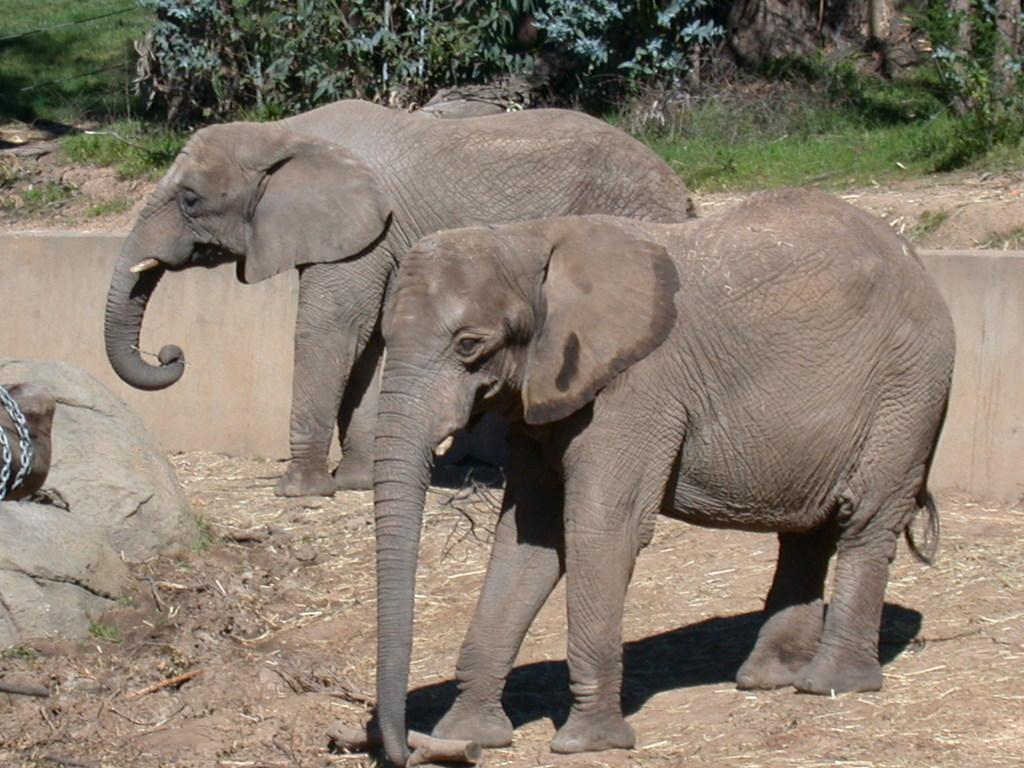What animals are present on the ground in the image? There are elephants on the ground in the image. What type of natural elements can be seen in the image? Rocks are visible in the image. What object is present in the image that might be used for restraining or connecting? There is a chain in the image. What can be seen in the background of the image? There is a wall, grass, and plants in the background of the image. What type of shirt is the elephant wearing in the image? Elephants do not wear shirts, and there is no clothing visible in the image. Can you tell me how many berries are growing on the plants in the image? There are no berries present in the image; only rocks, a chain, and plants can be seen. 